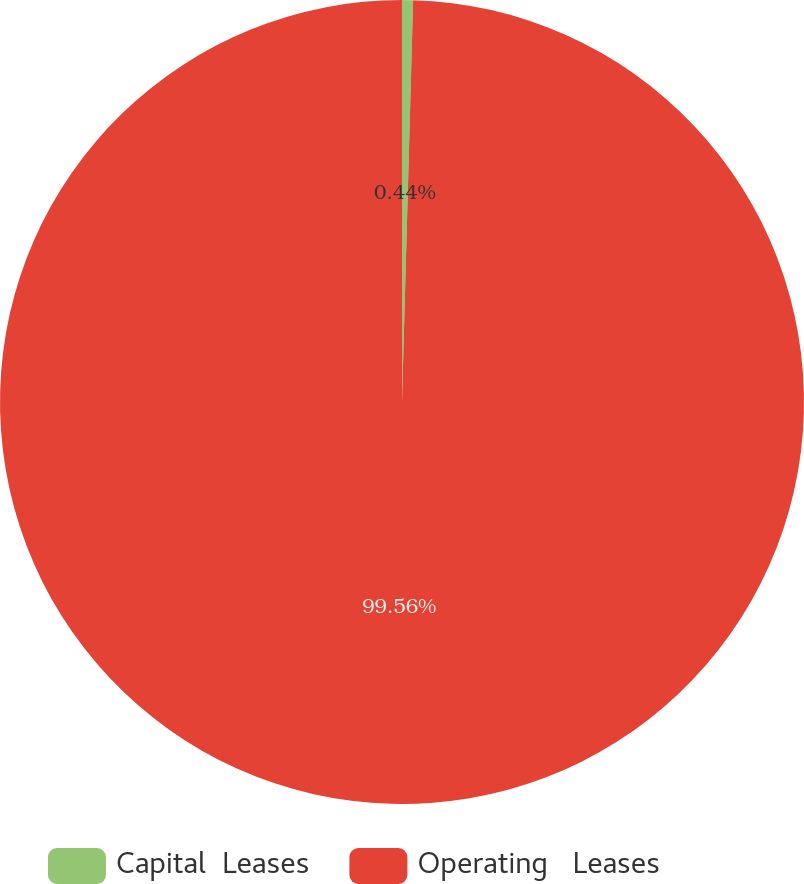Convert chart to OTSL. <chart><loc_0><loc_0><loc_500><loc_500><pie_chart><fcel>Capital  Leases<fcel>Operating   Leases<nl><fcel>0.44%<fcel>99.56%<nl></chart> 